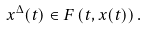<formula> <loc_0><loc_0><loc_500><loc_500>x ^ { \Delta } ( t ) \in F \left ( t , x ( t ) \right ) .</formula> 